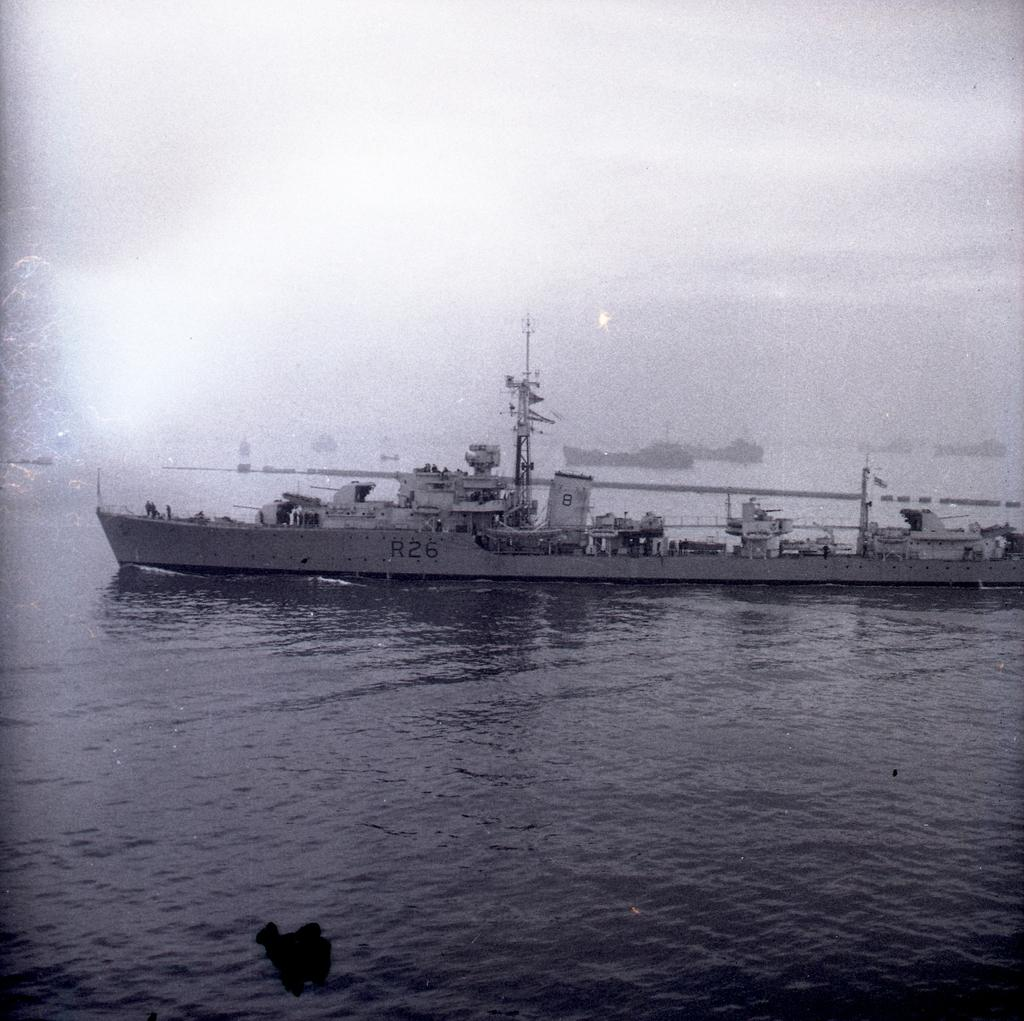What is the color scheme of the image? The image is black and white. What is the main subject in the middle of the image? There is a ship in the middle of the image. Where is the ship located? The ship is on the water. Can you describe the background of the image? There are more ships visible in the background. What is visible at the top of the image? The sky is visible at the top of the image. How many worms can be seen crawling on the ship in the image? There are no worms present in the image; it features a ship on the water with other ships in the background. 